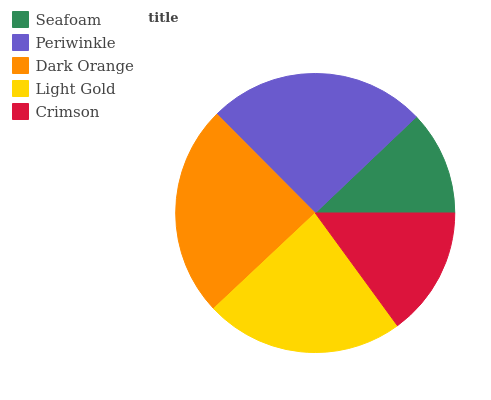Is Seafoam the minimum?
Answer yes or no. Yes. Is Periwinkle the maximum?
Answer yes or no. Yes. Is Dark Orange the minimum?
Answer yes or no. No. Is Dark Orange the maximum?
Answer yes or no. No. Is Periwinkle greater than Dark Orange?
Answer yes or no. Yes. Is Dark Orange less than Periwinkle?
Answer yes or no. Yes. Is Dark Orange greater than Periwinkle?
Answer yes or no. No. Is Periwinkle less than Dark Orange?
Answer yes or no. No. Is Light Gold the high median?
Answer yes or no. Yes. Is Light Gold the low median?
Answer yes or no. Yes. Is Periwinkle the high median?
Answer yes or no. No. Is Periwinkle the low median?
Answer yes or no. No. 